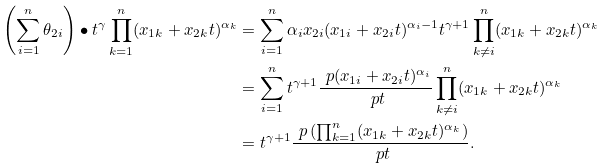Convert formula to latex. <formula><loc_0><loc_0><loc_500><loc_500>\left ( \sum _ { i = 1 } ^ { n } \theta _ { 2 i } \right ) \bullet t ^ { \gamma } \prod _ { k = 1 } ^ { n } ( x _ { 1 k } + x _ { 2 k } t ) ^ { \alpha _ { k } } & = \sum _ { i = 1 } ^ { n } \alpha _ { i } x _ { 2 i } ( x _ { 1 i } + x _ { 2 i } t ) ^ { \alpha _ { i } - 1 } t ^ { \gamma + 1 } \prod _ { k \ne i } ^ { n } ( x _ { 1 k } + x _ { 2 k } t ) ^ { \alpha _ { k } } \\ & = \sum _ { i = 1 } ^ { n } t ^ { \gamma + 1 } \frac { \ p ( x _ { 1 i } + x _ { 2 i } t ) ^ { \alpha _ { i } } } { \ p t } \prod _ { k \ne i } ^ { n } ( x _ { 1 k } + x _ { 2 k } t ) ^ { \alpha _ { k } } \\ & = t ^ { \gamma + 1 } \frac { \ p \left ( \prod _ { k = 1 } ^ { n } ( x _ { 1 k } + x _ { 2 k } t ) ^ { \alpha _ { k } } \right ) } { \ p t } .</formula> 